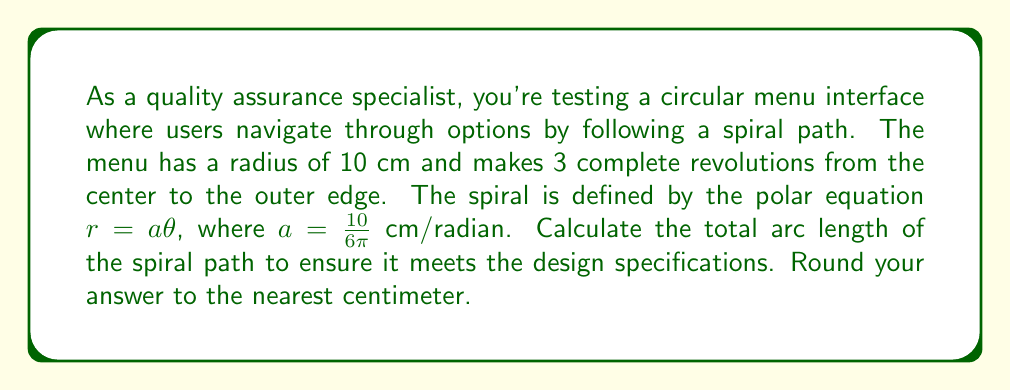Can you answer this question? To solve this problem, we'll use the formula for arc length in polar coordinates and follow these steps:

1) The formula for arc length in polar coordinates is:

   $$L = \int_{\theta_1}^{\theta_2} \sqrt{r^2 + \left(\frac{dr}{d\theta}\right)^2} d\theta$$

2) Given: $r = a\theta$, where $a = \frac{10}{6\pi}$ cm/radian

3) We need to find $\frac{dr}{d\theta}$:
   
   $$\frac{dr}{d\theta} = a = \frac{10}{6\pi}$$

4) Substituting into the arc length formula:

   $$L = \int_0^{6\pi} \sqrt{\left(a\theta\right)^2 + a^2} d\theta$$

5) Simplifying inside the square root:

   $$L = \int_0^{6\pi} \sqrt{a^2\theta^2 + a^2} d\theta = a\int_0^{6\pi} \sqrt{\theta^2 + 1} d\theta$$

6) This integral can be solved using the substitution $\theta = \sinh u$:

   $$L = a\left[\frac{1}{2}\theta\sqrt{\theta^2+1} + \frac{1}{2}\ln(\theta + \sqrt{\theta^2+1})\right]_0^{6\pi}$$

7) Evaluating the limits:

   $$L = \frac{10}{6\pi}\left[\frac{1}{2}(6\pi)\sqrt{(6\pi)^2+1} + \frac{1}{2}\ln(6\pi + \sqrt{(6\pi)^2+1}) - 0\right]$$

8) Calculating the result:

   $$L \approx 31.62 \text{ cm}$$

9) Rounding to the nearest centimeter:

   $$L \approx 32 \text{ cm}$$
Answer: 32 cm 